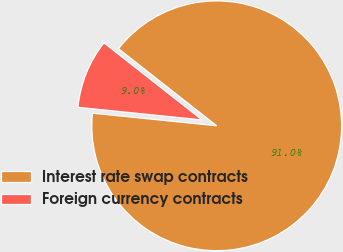Convert chart to OTSL. <chart><loc_0><loc_0><loc_500><loc_500><pie_chart><fcel>Interest rate swap contracts<fcel>Foreign currency contracts<nl><fcel>91.02%<fcel>8.98%<nl></chart> 